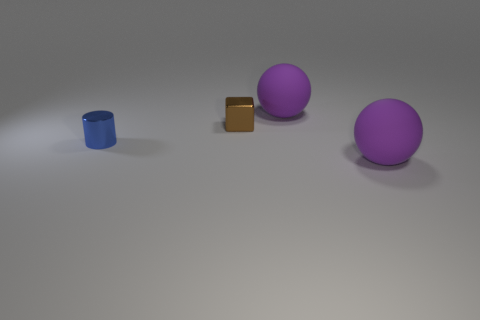What number of brown metallic blocks are there?
Ensure brevity in your answer.  1. Are there any other tiny blocks of the same color as the tiny cube?
Ensure brevity in your answer.  No. The large sphere in front of the tiny metallic thing that is left of the tiny thing behind the tiny blue cylinder is what color?
Your response must be concise. Purple. Is the block made of the same material as the purple ball in front of the small blue cylinder?
Provide a succinct answer. No. What number of other things are there of the same material as the small cylinder
Keep it short and to the point. 1. What shape is the thing that is both right of the tiny brown block and in front of the brown shiny block?
Your answer should be compact. Sphere. What is the color of the thing that is the same material as the cylinder?
Provide a short and direct response. Brown. Are there an equal number of brown metallic cubes behind the brown cube and large purple matte things?
Ensure brevity in your answer.  No. The brown metal object that is the same size as the blue metal object is what shape?
Provide a succinct answer. Cube. How many other objects are there of the same shape as the brown object?
Your answer should be very brief. 0. 